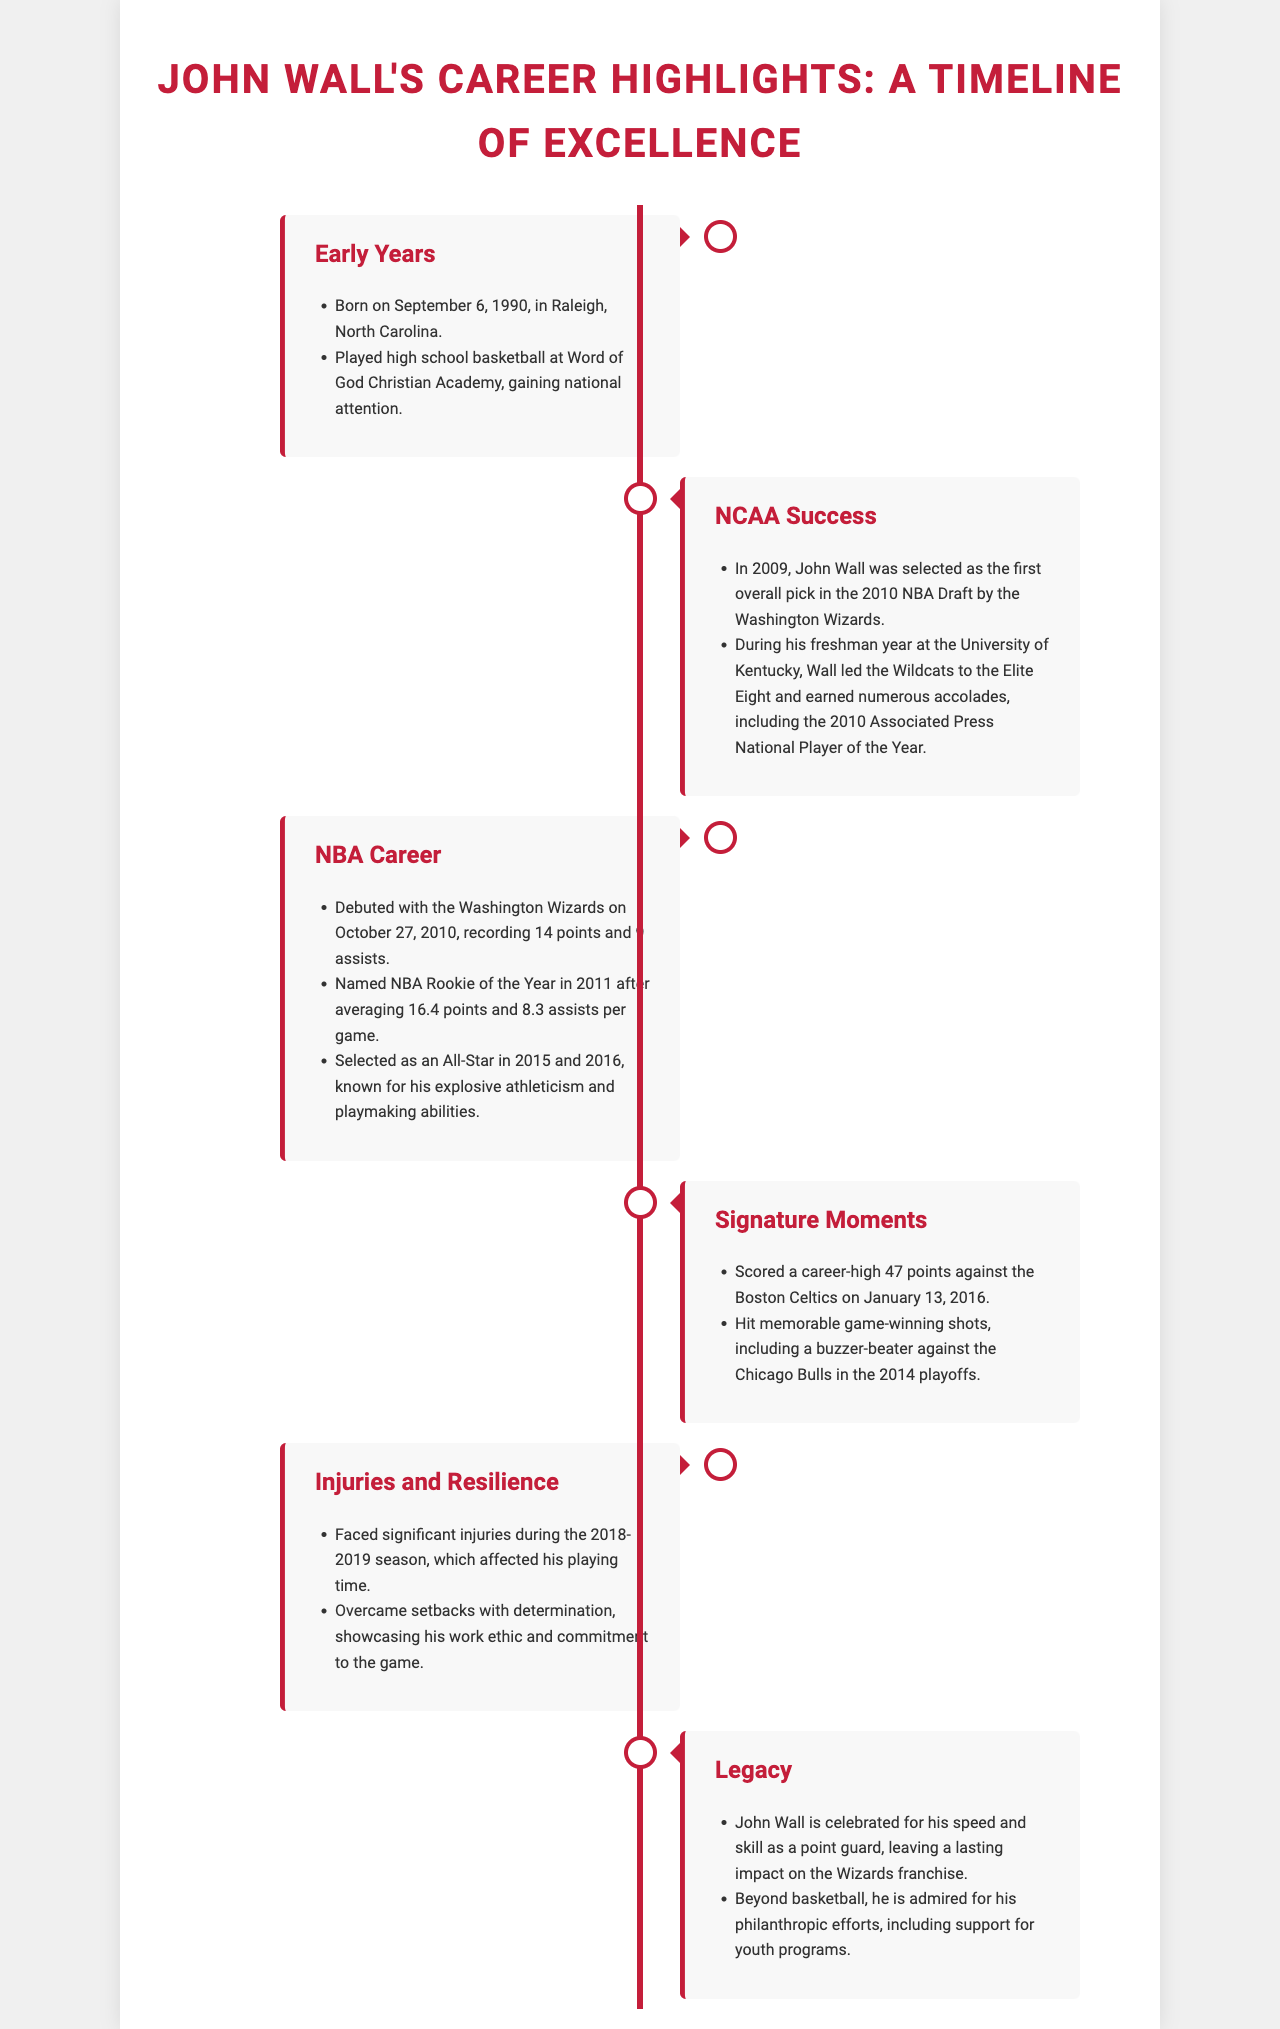what date was John Wall born? The document states that John Wall was born on September 6, 1990.
Answer: September 6, 1990 who was selected as the first overall pick in the 2010 NBA Draft? The document indicates that John Wall was selected as the first overall pick in the 2010 NBA Draft by the Washington Wizards.
Answer: John Wall how many points did John Wall score in his debut game? The document mentions that John Wall recorded 14 points in his debut game with the Wizards.
Answer: 14 points what awards did John Wall earn during his freshman year at the University of Kentucky? The document states that John Wall earned numerous accolades, including the 2010 Associated Press National Player of the Year.
Answer: Associated Press National Player of the Year what significant injuries did John Wall face? The document details that John Wall faced significant injuries during the 2018-2019 season, affecting his playing time.
Answer: 2018-2019 season which team did John Wall score a career-high against? The document indicates that John Wall scored a career-high 47 points against the Boston Celtics.
Answer: Boston Celtics what is John Wall celebrated for as a player? The document states that John Wall is celebrated for his speed and skill as a point guard.
Answer: speed and skill as a point guard in which years was John Wall selected as an All-Star? The document specifies that John Wall was selected as an All-Star in 2015 and 2016.
Answer: 2015 and 2016 what is a notable moment from the 2014 playoffs involving John Wall? The document mentions that John Wall hit a memorable game-winning shot, including a buzzer-beater against the Chicago Bulls in the 2014 playoffs.
Answer: buzzer-beater against the Chicago Bulls 